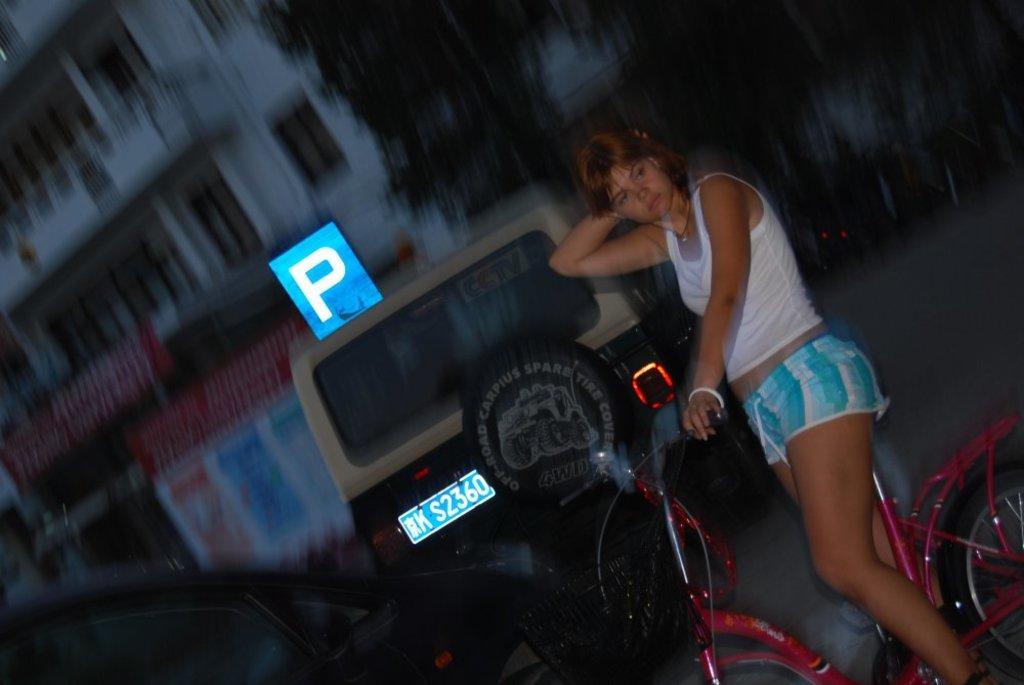Describe this image in one or two sentences. In this image I can see a woman on a cycle. In the background I can see few vehicles, trees and a building. 